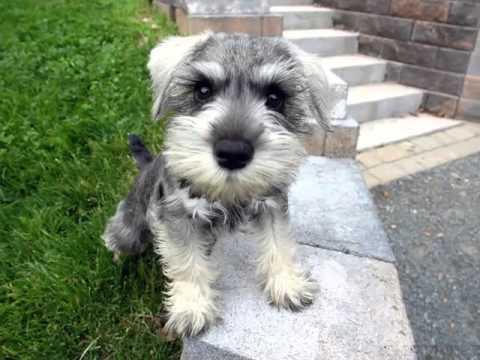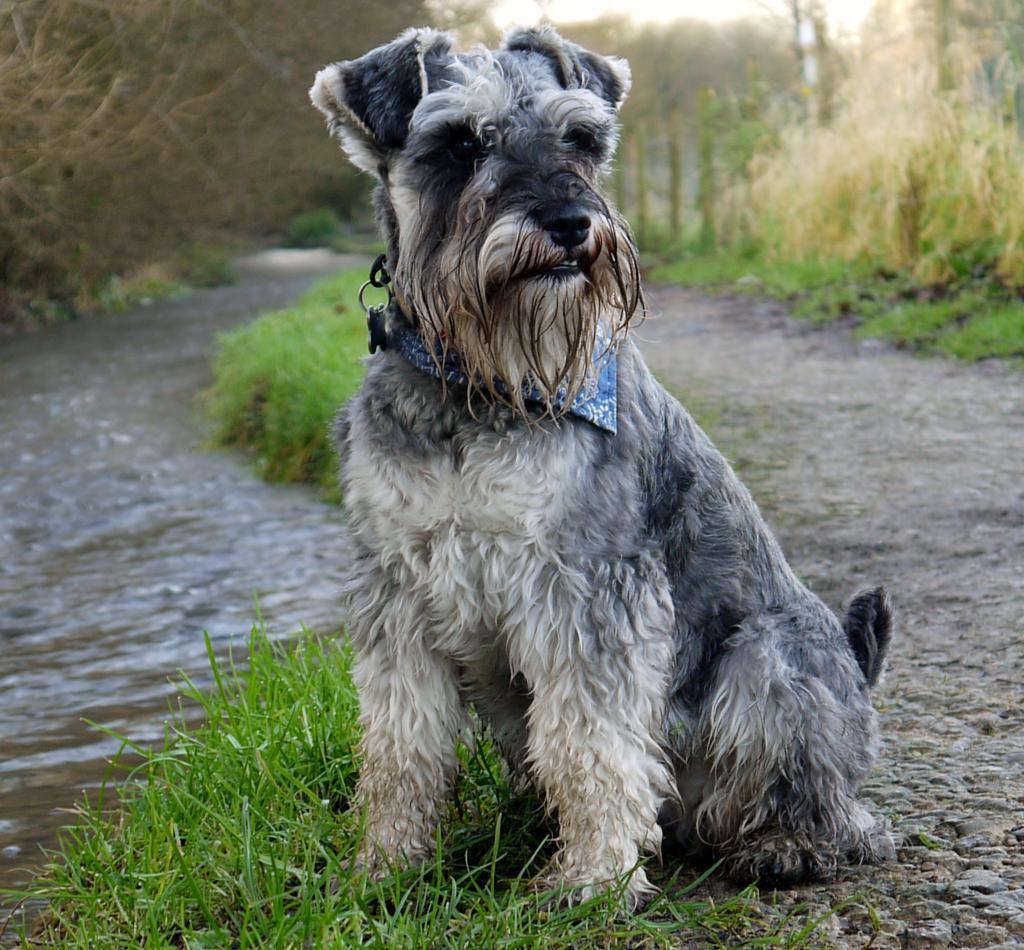The first image is the image on the left, the second image is the image on the right. For the images displayed, is the sentence "At least one of the dogs is indoors." factually correct? Answer yes or no. No. 